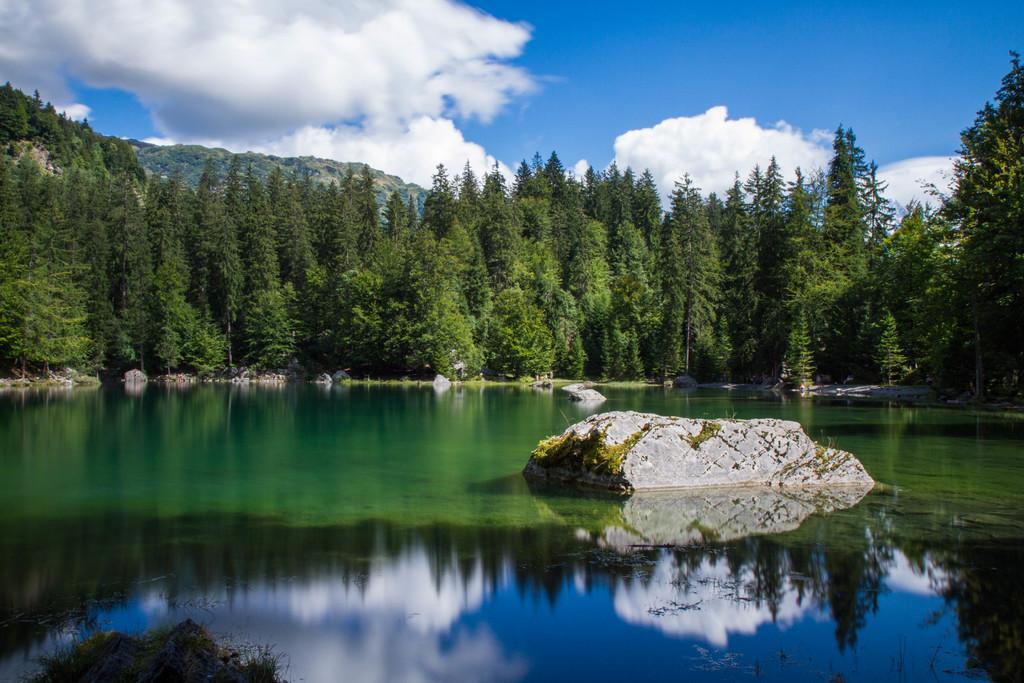How would you summarize this image in a sentence or two? At the bottom we can see water and a rock in the middle of the water. In the background there are trees, mountain and clouds in the sky. 